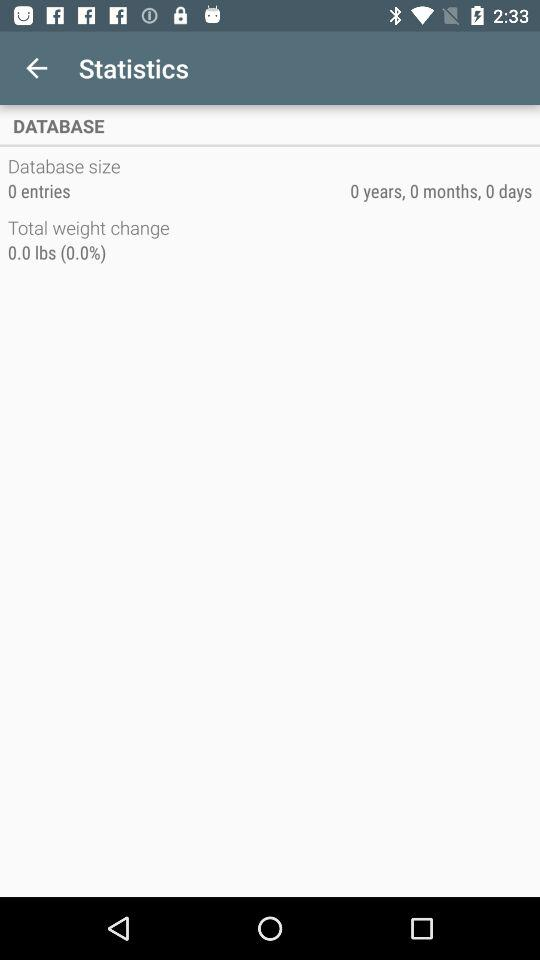What is the duration of database?
When the provided information is insufficient, respond with <no answer>. <no answer> 